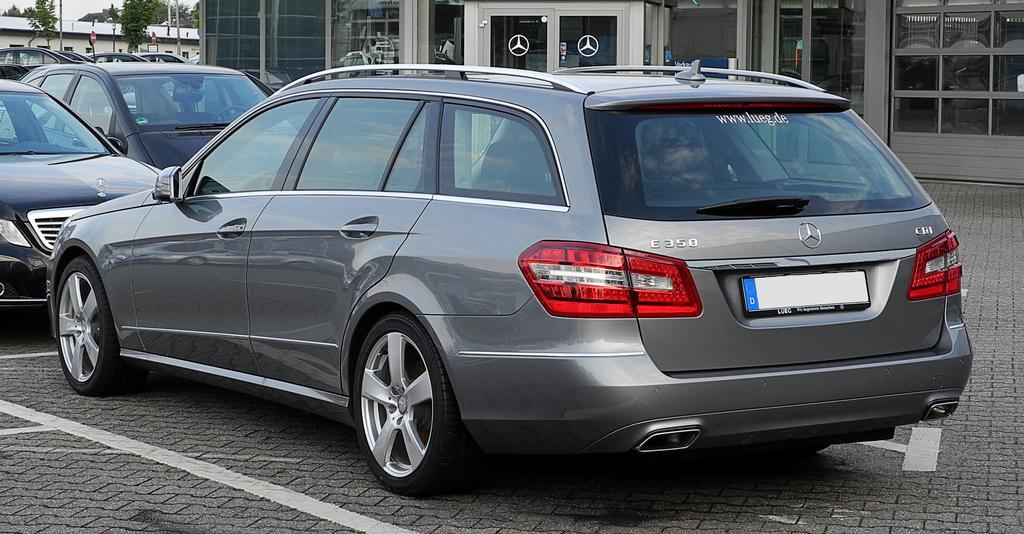Could you give a brief overview of what you see in this image? This picture shows a few cars parked and we see buildings and trees and couple of sign boards. 